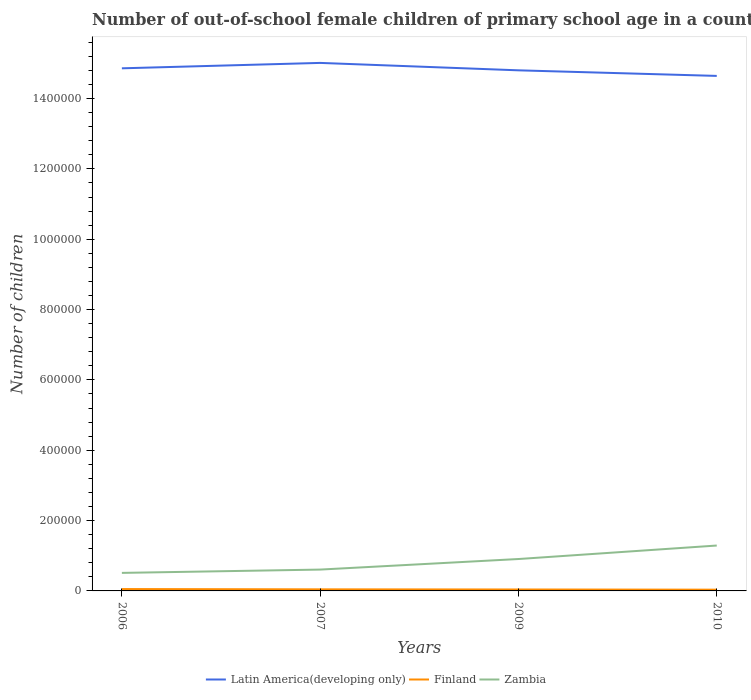Does the line corresponding to Latin America(developing only) intersect with the line corresponding to Finland?
Keep it short and to the point. No. Is the number of lines equal to the number of legend labels?
Offer a terse response. Yes. Across all years, what is the maximum number of out-of-school female children in Zambia?
Offer a very short reply. 5.13e+04. In which year was the number of out-of-school female children in Zambia maximum?
Ensure brevity in your answer.  2006. What is the total number of out-of-school female children in Zambia in the graph?
Your response must be concise. -3.00e+04. What is the difference between the highest and the second highest number of out-of-school female children in Latin America(developing only)?
Your answer should be compact. 3.70e+04. What is the difference between the highest and the lowest number of out-of-school female children in Zambia?
Keep it short and to the point. 2. Is the number of out-of-school female children in Finland strictly greater than the number of out-of-school female children in Latin America(developing only) over the years?
Keep it short and to the point. Yes. How many lines are there?
Offer a very short reply. 3. How many years are there in the graph?
Offer a very short reply. 4. What is the difference between two consecutive major ticks on the Y-axis?
Provide a short and direct response. 2.00e+05. Are the values on the major ticks of Y-axis written in scientific E-notation?
Offer a very short reply. No. Does the graph contain any zero values?
Keep it short and to the point. No. How are the legend labels stacked?
Offer a terse response. Horizontal. What is the title of the graph?
Your answer should be compact. Number of out-of-school female children of primary school age in a country. Does "Armenia" appear as one of the legend labels in the graph?
Keep it short and to the point. No. What is the label or title of the Y-axis?
Keep it short and to the point. Number of children. What is the Number of children in Latin America(developing only) in 2006?
Provide a short and direct response. 1.49e+06. What is the Number of children of Finland in 2006?
Your response must be concise. 5293. What is the Number of children in Zambia in 2006?
Make the answer very short. 5.13e+04. What is the Number of children of Latin America(developing only) in 2007?
Give a very brief answer. 1.50e+06. What is the Number of children in Finland in 2007?
Make the answer very short. 4464. What is the Number of children in Zambia in 2007?
Offer a very short reply. 6.07e+04. What is the Number of children of Latin America(developing only) in 2009?
Make the answer very short. 1.48e+06. What is the Number of children of Finland in 2009?
Offer a terse response. 4085. What is the Number of children in Zambia in 2009?
Provide a succinct answer. 9.07e+04. What is the Number of children in Latin America(developing only) in 2010?
Keep it short and to the point. 1.46e+06. What is the Number of children of Finland in 2010?
Your answer should be compact. 3564. What is the Number of children in Zambia in 2010?
Provide a succinct answer. 1.29e+05. Across all years, what is the maximum Number of children in Latin America(developing only)?
Your answer should be compact. 1.50e+06. Across all years, what is the maximum Number of children of Finland?
Keep it short and to the point. 5293. Across all years, what is the maximum Number of children of Zambia?
Make the answer very short. 1.29e+05. Across all years, what is the minimum Number of children in Latin America(developing only)?
Provide a succinct answer. 1.46e+06. Across all years, what is the minimum Number of children in Finland?
Keep it short and to the point. 3564. Across all years, what is the minimum Number of children in Zambia?
Offer a terse response. 5.13e+04. What is the total Number of children of Latin America(developing only) in the graph?
Offer a very short reply. 5.93e+06. What is the total Number of children in Finland in the graph?
Keep it short and to the point. 1.74e+04. What is the total Number of children in Zambia in the graph?
Make the answer very short. 3.32e+05. What is the difference between the Number of children in Latin America(developing only) in 2006 and that in 2007?
Your answer should be compact. -1.53e+04. What is the difference between the Number of children in Finland in 2006 and that in 2007?
Ensure brevity in your answer.  829. What is the difference between the Number of children in Zambia in 2006 and that in 2007?
Make the answer very short. -9399. What is the difference between the Number of children in Latin America(developing only) in 2006 and that in 2009?
Ensure brevity in your answer.  5729. What is the difference between the Number of children of Finland in 2006 and that in 2009?
Provide a succinct answer. 1208. What is the difference between the Number of children of Zambia in 2006 and that in 2009?
Provide a succinct answer. -3.94e+04. What is the difference between the Number of children in Latin America(developing only) in 2006 and that in 2010?
Make the answer very short. 2.16e+04. What is the difference between the Number of children in Finland in 2006 and that in 2010?
Your answer should be compact. 1729. What is the difference between the Number of children in Zambia in 2006 and that in 2010?
Your response must be concise. -7.78e+04. What is the difference between the Number of children of Latin America(developing only) in 2007 and that in 2009?
Keep it short and to the point. 2.11e+04. What is the difference between the Number of children in Finland in 2007 and that in 2009?
Provide a succinct answer. 379. What is the difference between the Number of children of Zambia in 2007 and that in 2009?
Offer a very short reply. -3.00e+04. What is the difference between the Number of children in Latin America(developing only) in 2007 and that in 2010?
Your answer should be compact. 3.70e+04. What is the difference between the Number of children in Finland in 2007 and that in 2010?
Give a very brief answer. 900. What is the difference between the Number of children in Zambia in 2007 and that in 2010?
Keep it short and to the point. -6.84e+04. What is the difference between the Number of children in Latin America(developing only) in 2009 and that in 2010?
Offer a very short reply. 1.59e+04. What is the difference between the Number of children in Finland in 2009 and that in 2010?
Your response must be concise. 521. What is the difference between the Number of children of Zambia in 2009 and that in 2010?
Your answer should be compact. -3.83e+04. What is the difference between the Number of children of Latin America(developing only) in 2006 and the Number of children of Finland in 2007?
Provide a succinct answer. 1.48e+06. What is the difference between the Number of children of Latin America(developing only) in 2006 and the Number of children of Zambia in 2007?
Your response must be concise. 1.43e+06. What is the difference between the Number of children of Finland in 2006 and the Number of children of Zambia in 2007?
Provide a succinct answer. -5.54e+04. What is the difference between the Number of children of Latin America(developing only) in 2006 and the Number of children of Finland in 2009?
Ensure brevity in your answer.  1.48e+06. What is the difference between the Number of children of Latin America(developing only) in 2006 and the Number of children of Zambia in 2009?
Ensure brevity in your answer.  1.40e+06. What is the difference between the Number of children of Finland in 2006 and the Number of children of Zambia in 2009?
Give a very brief answer. -8.54e+04. What is the difference between the Number of children of Latin America(developing only) in 2006 and the Number of children of Finland in 2010?
Your answer should be compact. 1.48e+06. What is the difference between the Number of children of Latin America(developing only) in 2006 and the Number of children of Zambia in 2010?
Your answer should be very brief. 1.36e+06. What is the difference between the Number of children in Finland in 2006 and the Number of children in Zambia in 2010?
Make the answer very short. -1.24e+05. What is the difference between the Number of children in Latin America(developing only) in 2007 and the Number of children in Finland in 2009?
Your answer should be compact. 1.50e+06. What is the difference between the Number of children in Latin America(developing only) in 2007 and the Number of children in Zambia in 2009?
Offer a terse response. 1.41e+06. What is the difference between the Number of children in Finland in 2007 and the Number of children in Zambia in 2009?
Keep it short and to the point. -8.62e+04. What is the difference between the Number of children in Latin America(developing only) in 2007 and the Number of children in Finland in 2010?
Your response must be concise. 1.50e+06. What is the difference between the Number of children in Latin America(developing only) in 2007 and the Number of children in Zambia in 2010?
Your answer should be compact. 1.37e+06. What is the difference between the Number of children of Finland in 2007 and the Number of children of Zambia in 2010?
Keep it short and to the point. -1.25e+05. What is the difference between the Number of children of Latin America(developing only) in 2009 and the Number of children of Finland in 2010?
Keep it short and to the point. 1.48e+06. What is the difference between the Number of children of Latin America(developing only) in 2009 and the Number of children of Zambia in 2010?
Provide a short and direct response. 1.35e+06. What is the difference between the Number of children in Finland in 2009 and the Number of children in Zambia in 2010?
Provide a short and direct response. -1.25e+05. What is the average Number of children in Latin America(developing only) per year?
Provide a short and direct response. 1.48e+06. What is the average Number of children in Finland per year?
Make the answer very short. 4351.5. What is the average Number of children of Zambia per year?
Keep it short and to the point. 8.29e+04. In the year 2006, what is the difference between the Number of children of Latin America(developing only) and Number of children of Finland?
Give a very brief answer. 1.48e+06. In the year 2006, what is the difference between the Number of children in Latin America(developing only) and Number of children in Zambia?
Provide a short and direct response. 1.43e+06. In the year 2006, what is the difference between the Number of children in Finland and Number of children in Zambia?
Offer a very short reply. -4.60e+04. In the year 2007, what is the difference between the Number of children in Latin America(developing only) and Number of children in Finland?
Provide a succinct answer. 1.50e+06. In the year 2007, what is the difference between the Number of children in Latin America(developing only) and Number of children in Zambia?
Offer a very short reply. 1.44e+06. In the year 2007, what is the difference between the Number of children in Finland and Number of children in Zambia?
Your answer should be compact. -5.62e+04. In the year 2009, what is the difference between the Number of children in Latin America(developing only) and Number of children in Finland?
Give a very brief answer. 1.48e+06. In the year 2009, what is the difference between the Number of children in Latin America(developing only) and Number of children in Zambia?
Your response must be concise. 1.39e+06. In the year 2009, what is the difference between the Number of children in Finland and Number of children in Zambia?
Your answer should be very brief. -8.66e+04. In the year 2010, what is the difference between the Number of children of Latin America(developing only) and Number of children of Finland?
Offer a very short reply. 1.46e+06. In the year 2010, what is the difference between the Number of children in Latin America(developing only) and Number of children in Zambia?
Your response must be concise. 1.34e+06. In the year 2010, what is the difference between the Number of children in Finland and Number of children in Zambia?
Ensure brevity in your answer.  -1.25e+05. What is the ratio of the Number of children in Finland in 2006 to that in 2007?
Give a very brief answer. 1.19. What is the ratio of the Number of children of Zambia in 2006 to that in 2007?
Your response must be concise. 0.85. What is the ratio of the Number of children of Finland in 2006 to that in 2009?
Your answer should be compact. 1.3. What is the ratio of the Number of children in Zambia in 2006 to that in 2009?
Your response must be concise. 0.57. What is the ratio of the Number of children of Latin America(developing only) in 2006 to that in 2010?
Offer a very short reply. 1.01. What is the ratio of the Number of children in Finland in 2006 to that in 2010?
Provide a succinct answer. 1.49. What is the ratio of the Number of children of Zambia in 2006 to that in 2010?
Offer a very short reply. 0.4. What is the ratio of the Number of children in Latin America(developing only) in 2007 to that in 2009?
Offer a terse response. 1.01. What is the ratio of the Number of children of Finland in 2007 to that in 2009?
Provide a succinct answer. 1.09. What is the ratio of the Number of children of Zambia in 2007 to that in 2009?
Provide a succinct answer. 0.67. What is the ratio of the Number of children in Latin America(developing only) in 2007 to that in 2010?
Offer a very short reply. 1.03. What is the ratio of the Number of children of Finland in 2007 to that in 2010?
Offer a terse response. 1.25. What is the ratio of the Number of children of Zambia in 2007 to that in 2010?
Your answer should be compact. 0.47. What is the ratio of the Number of children in Latin America(developing only) in 2009 to that in 2010?
Offer a very short reply. 1.01. What is the ratio of the Number of children of Finland in 2009 to that in 2010?
Offer a very short reply. 1.15. What is the ratio of the Number of children of Zambia in 2009 to that in 2010?
Your answer should be very brief. 0.7. What is the difference between the highest and the second highest Number of children in Latin America(developing only)?
Your answer should be very brief. 1.53e+04. What is the difference between the highest and the second highest Number of children in Finland?
Provide a short and direct response. 829. What is the difference between the highest and the second highest Number of children of Zambia?
Keep it short and to the point. 3.83e+04. What is the difference between the highest and the lowest Number of children in Latin America(developing only)?
Offer a terse response. 3.70e+04. What is the difference between the highest and the lowest Number of children of Finland?
Provide a succinct answer. 1729. What is the difference between the highest and the lowest Number of children in Zambia?
Keep it short and to the point. 7.78e+04. 